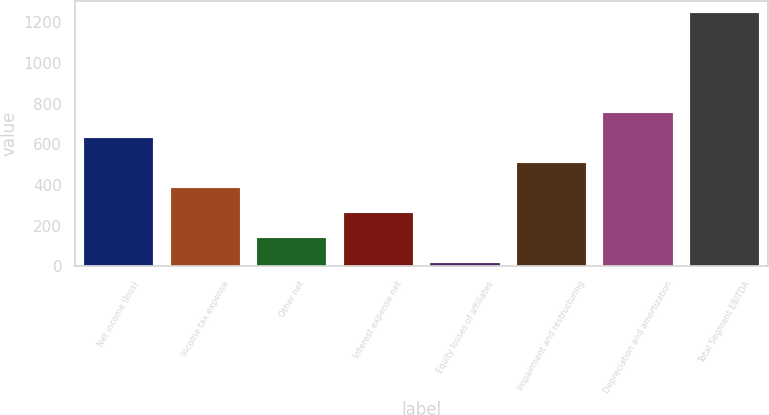Convert chart to OTSL. <chart><loc_0><loc_0><loc_500><loc_500><bar_chart><fcel>Net income (loss)<fcel>Income tax expense<fcel>Other net<fcel>Interest expense net<fcel>Equity losses of affiliates<fcel>Impairment and restructuring<fcel>Depreciation and amortization<fcel>Total Segment EBITDA<nl><fcel>630.5<fcel>385.1<fcel>139.7<fcel>262.4<fcel>17<fcel>507.8<fcel>753.2<fcel>1244<nl></chart> 